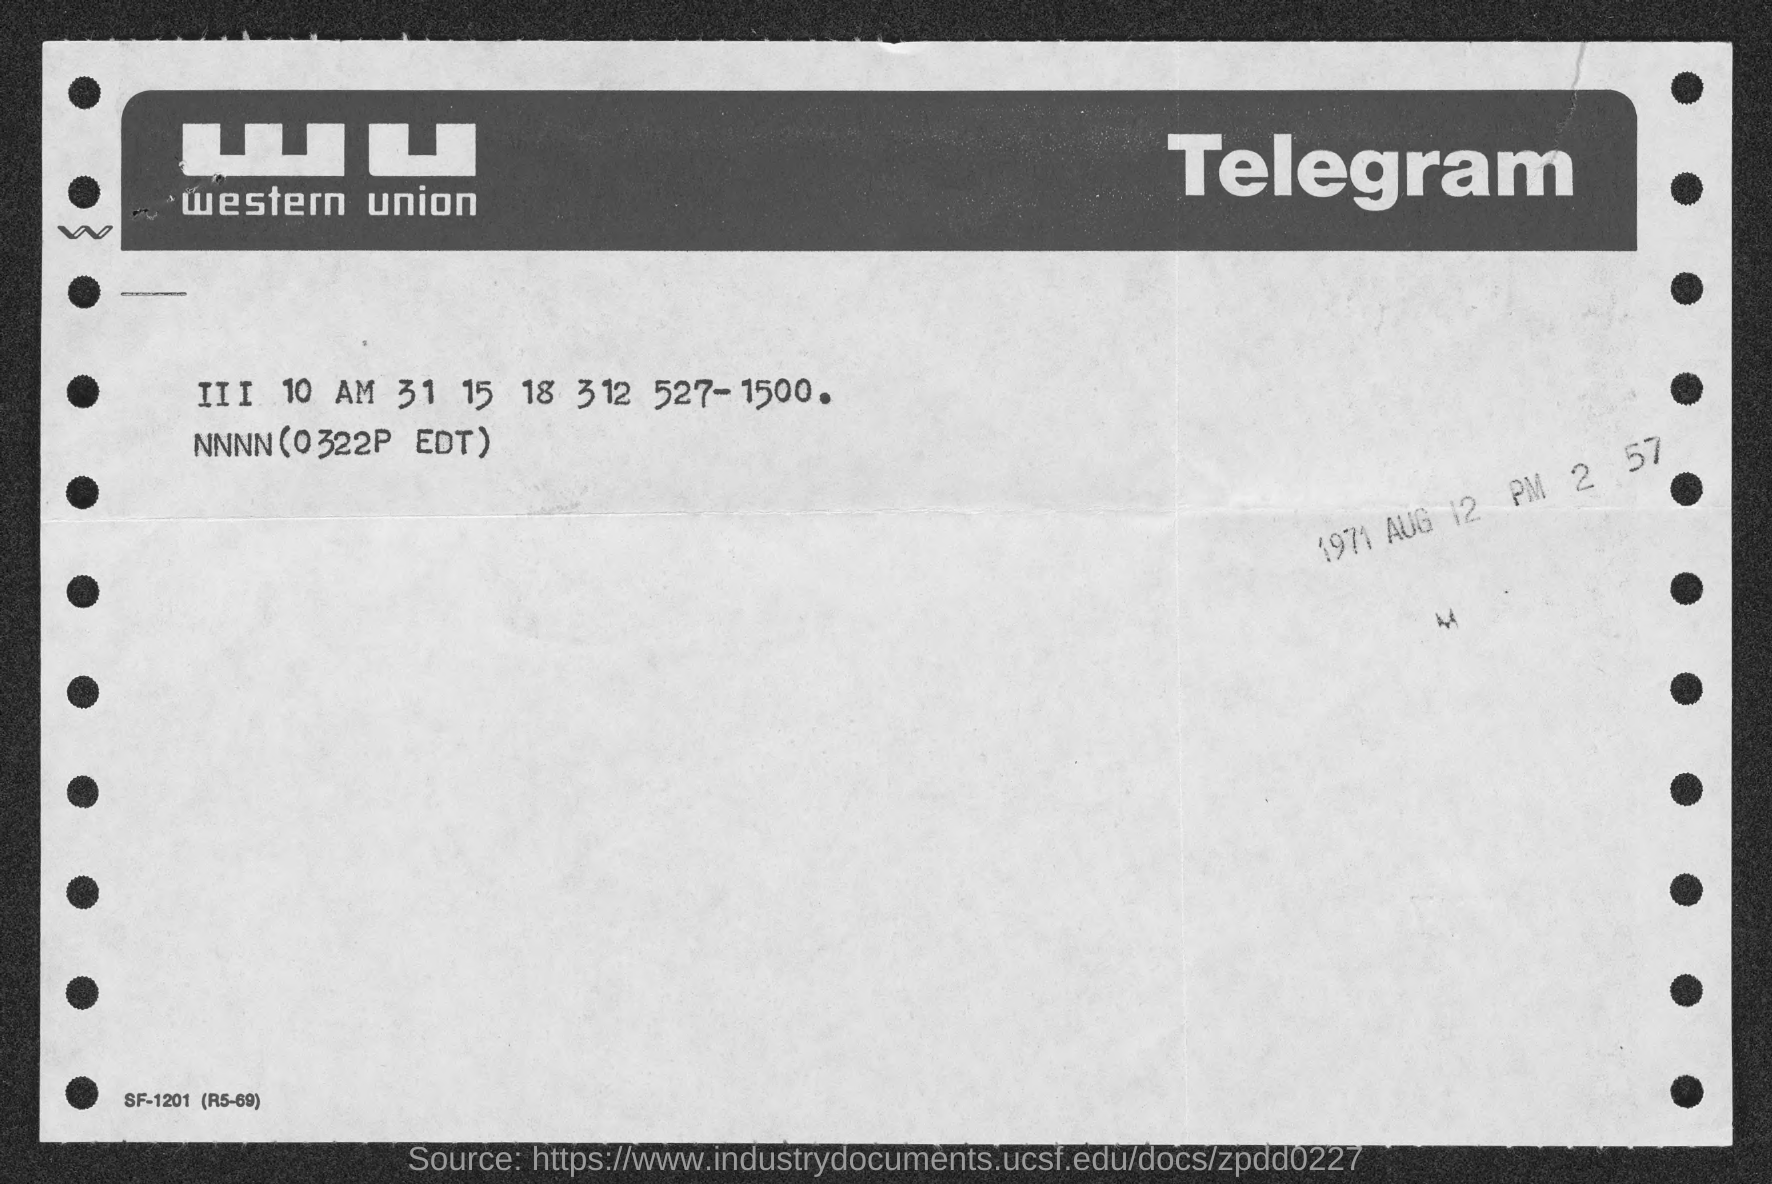What kind of communication is this ?
Make the answer very short. Telegram. 